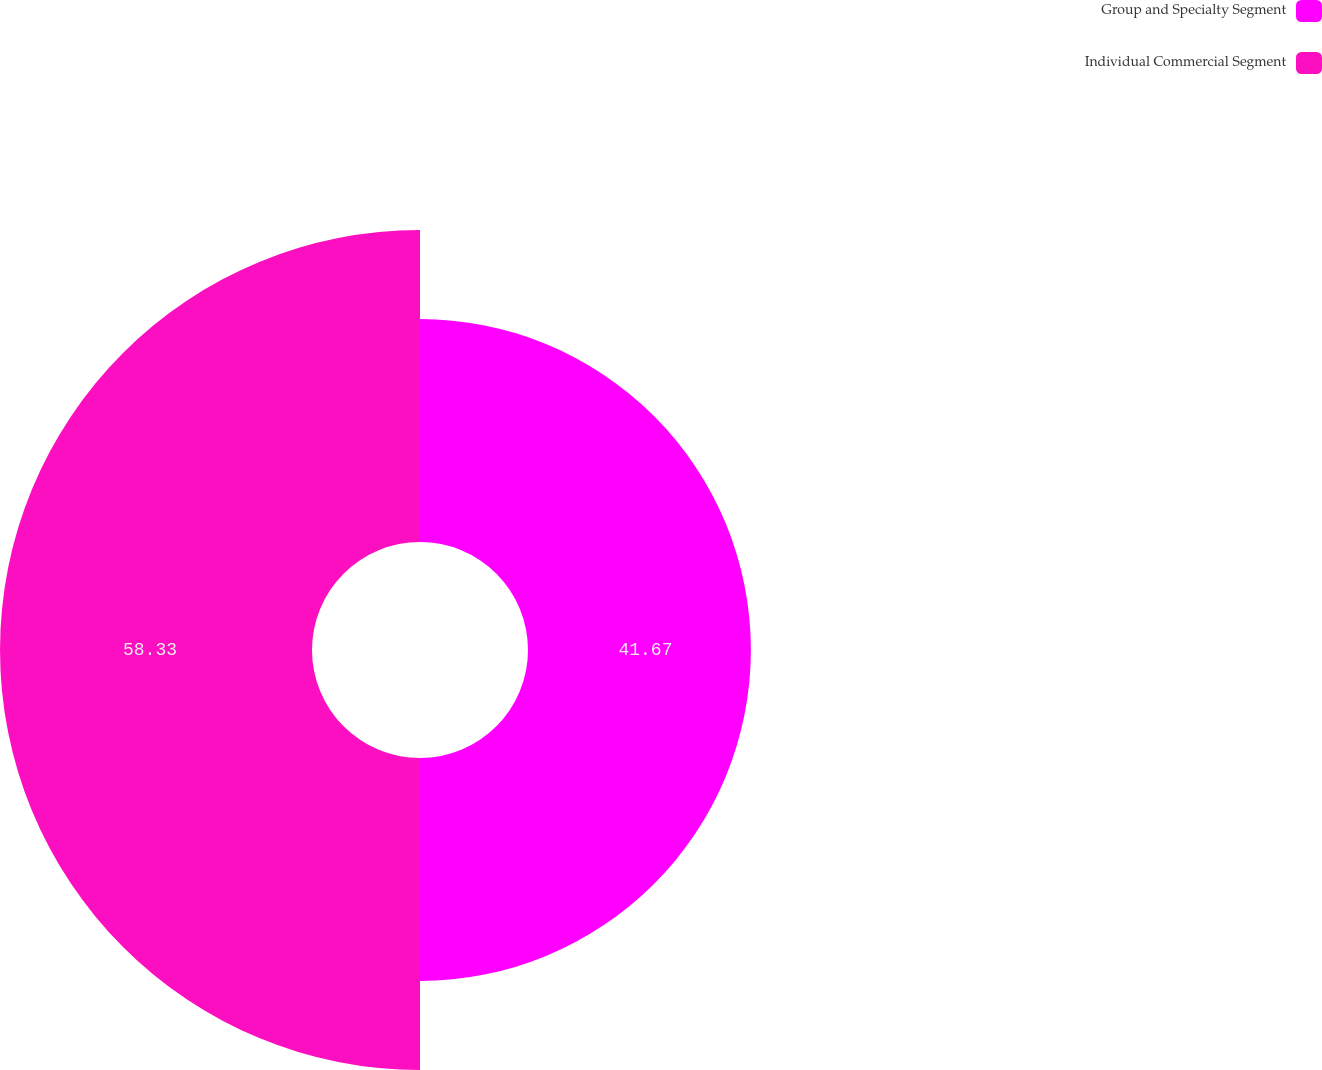Convert chart to OTSL. <chart><loc_0><loc_0><loc_500><loc_500><pie_chart><fcel>Group and Specialty Segment<fcel>Individual Commercial Segment<nl><fcel>41.67%<fcel>58.33%<nl></chart> 